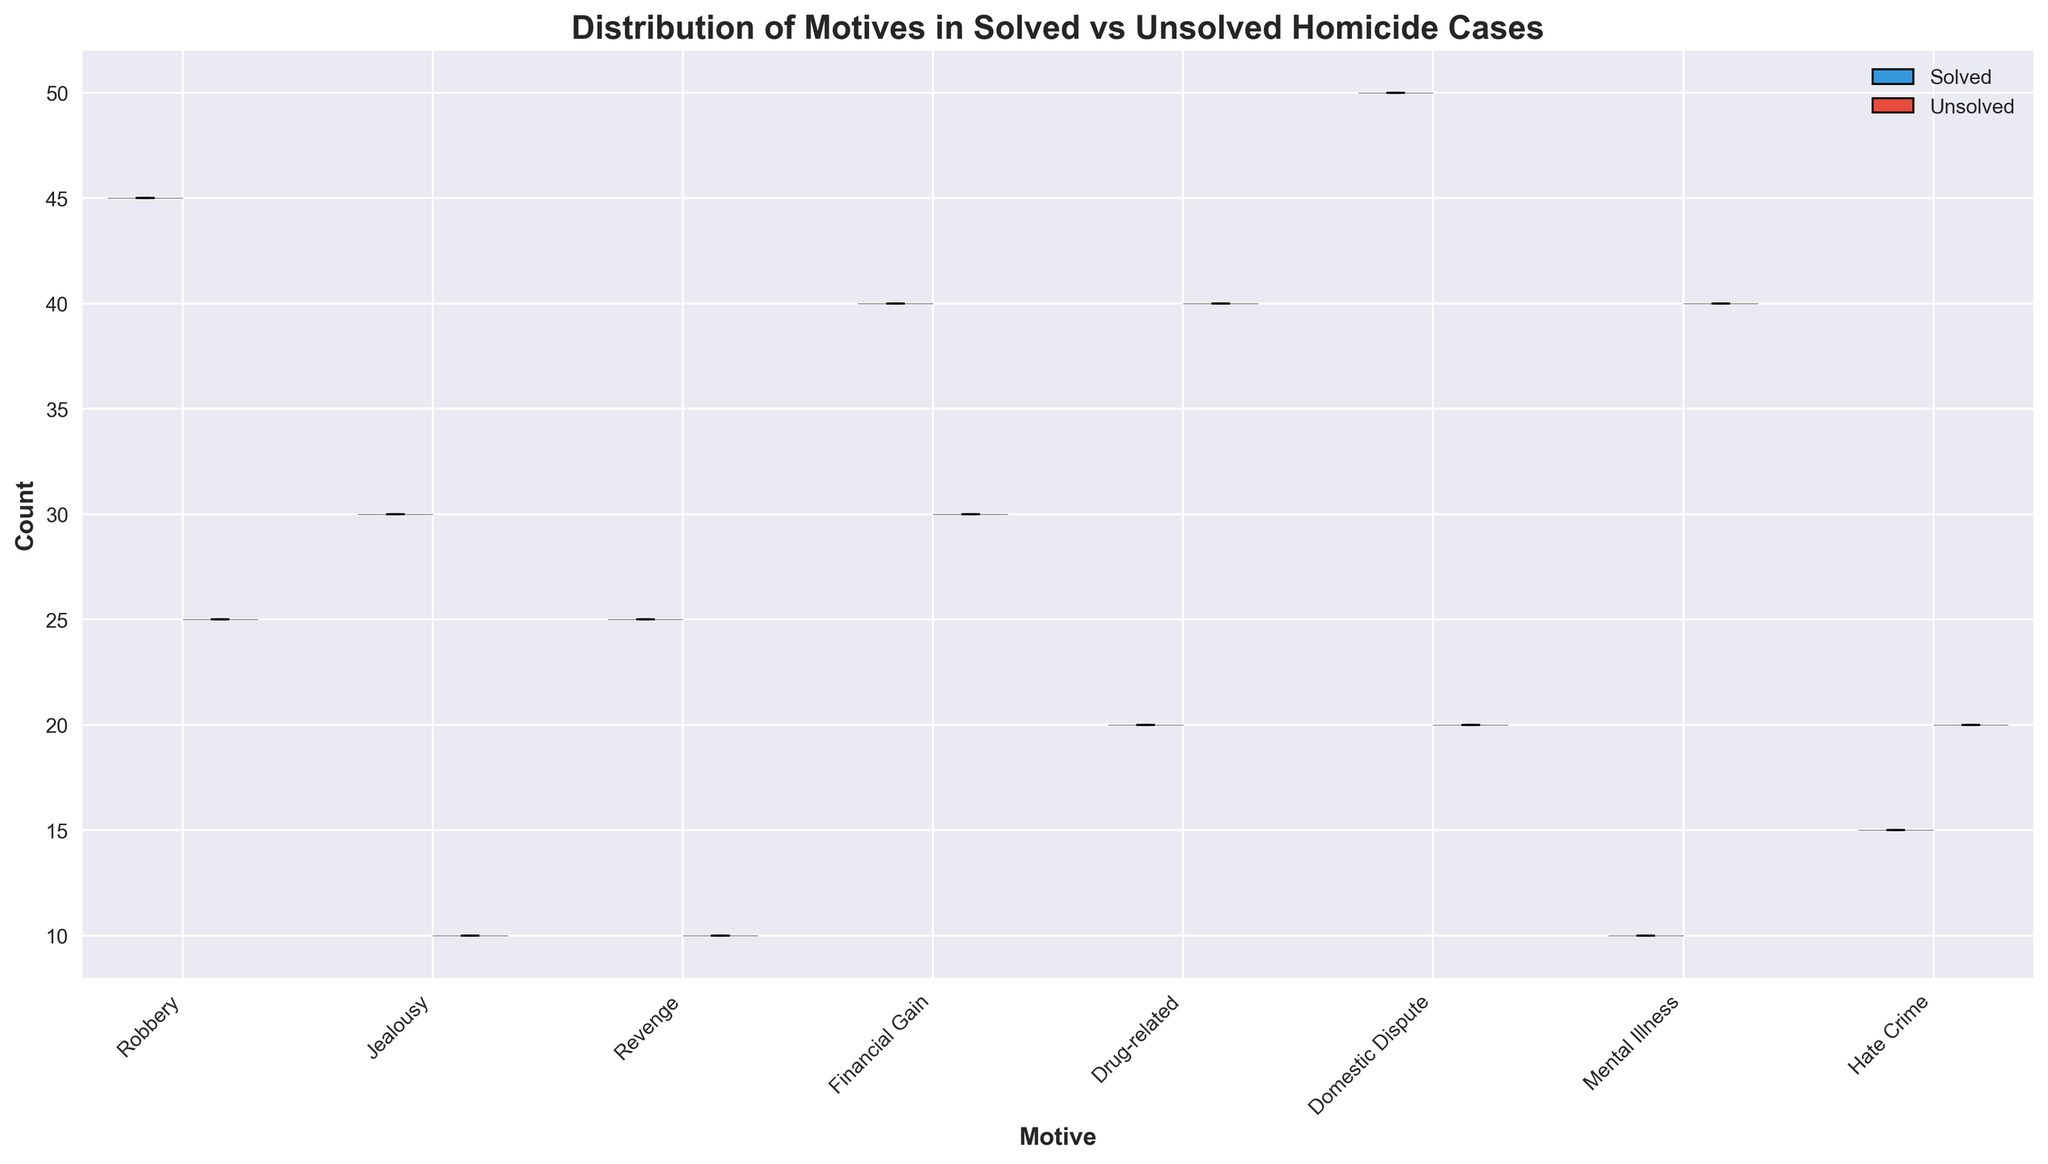What is the title of the plot? The title of the plot is written at the top and reads "Distribution of Motives in Solved vs Unsolved Homicide Cases".
Answer: Distribution of Motives in Solved vs Unsolved Homicide Cases What color are the box plots for solved cases? The box plots for solved cases are colored blue. This is indicated by the legend and visual appearance of the boxes on the plot.
Answer: Blue Which motive category has the highest number of solved cases? The motive category with the highest number of solved cases is indicated by the tallest and widest part of the corresponding violin plot. In this case, it is "Domestic Dispute".
Answer: Domestic Dispute For which motive are there more unsolved cases than solved cases? By comparing the heights and shapes of the violin plots for each motive, we see that "Drug-related" has more unsolved cases than solved cases as the red area is taller than the blue area.
Answer: Drug-related What is the median number of solved cases for the "Financial Gain" motive? The median number of solved cases is indicated by the horizontal black line within the blue box plot for "Financial Gain". The median value is approximately 40.
Answer: 40 How do the distributions of solved and unsolved cases for "Mental Illness" differ? By observing the width and shape of the violin plots, solved cases (blue) for "Mental Illness" have fewer counts and a narrower distribution compared to unsolved cases (red), which have a higher range and wider spread.
Answer: Unsolved counts are higher with a wider spread compared to solved counts Which motive has the smallest number of unsolved cases? By looking at the height and width of the red violin plots, the "Jealousy" motive has the smallest number of unsolved cases.
Answer: Jealousy Between solved and unsolved cases for the "Hate Crime" motive, which one has the larger interquartile range (IQR)? The interquartile range (IQR) is represented by the size of the box in the box plot. Comparing the boxes for "Hate Crime", the red box (unsolved) appears to have a larger IQR than the blue box (solved).
Answer: Unsolved What's the total number of cases for the "Revenge" motive combined from solved and unsolved cases? Adding the counts shown in both violin plots for "Revenge" motive: Solved (25) + Unsolved (10) = 35 total cases.
Answer: 35 Which two motives have the most similar distribution for solved cases? By comparing the shapes and distributions of the solved (blue) violin plots, it appears that "Jealousy" and "Financial Gain" have the most similar distribution, as their widths and heights are relatively comparable.
Answer: Jealousy and Financial Gain 